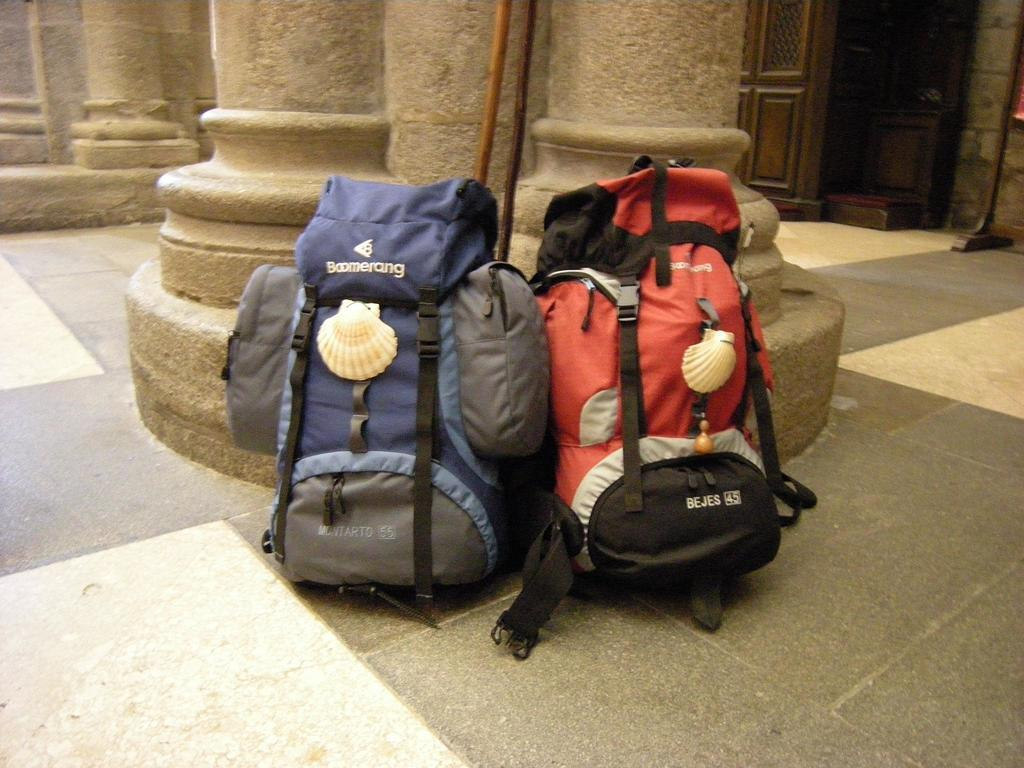How many bags are visible in the image? There are two bags in the image. Where is the first bag located? The first bag is on the left side. Where is the second bag located? The second bag is on the right side. What can be seen in the background of the image? There is a wooden door in the background of the image. What type of pin is being used to calculate the cloth's measurements in the image? There is no pin, calculator, or cloth present in the image. 